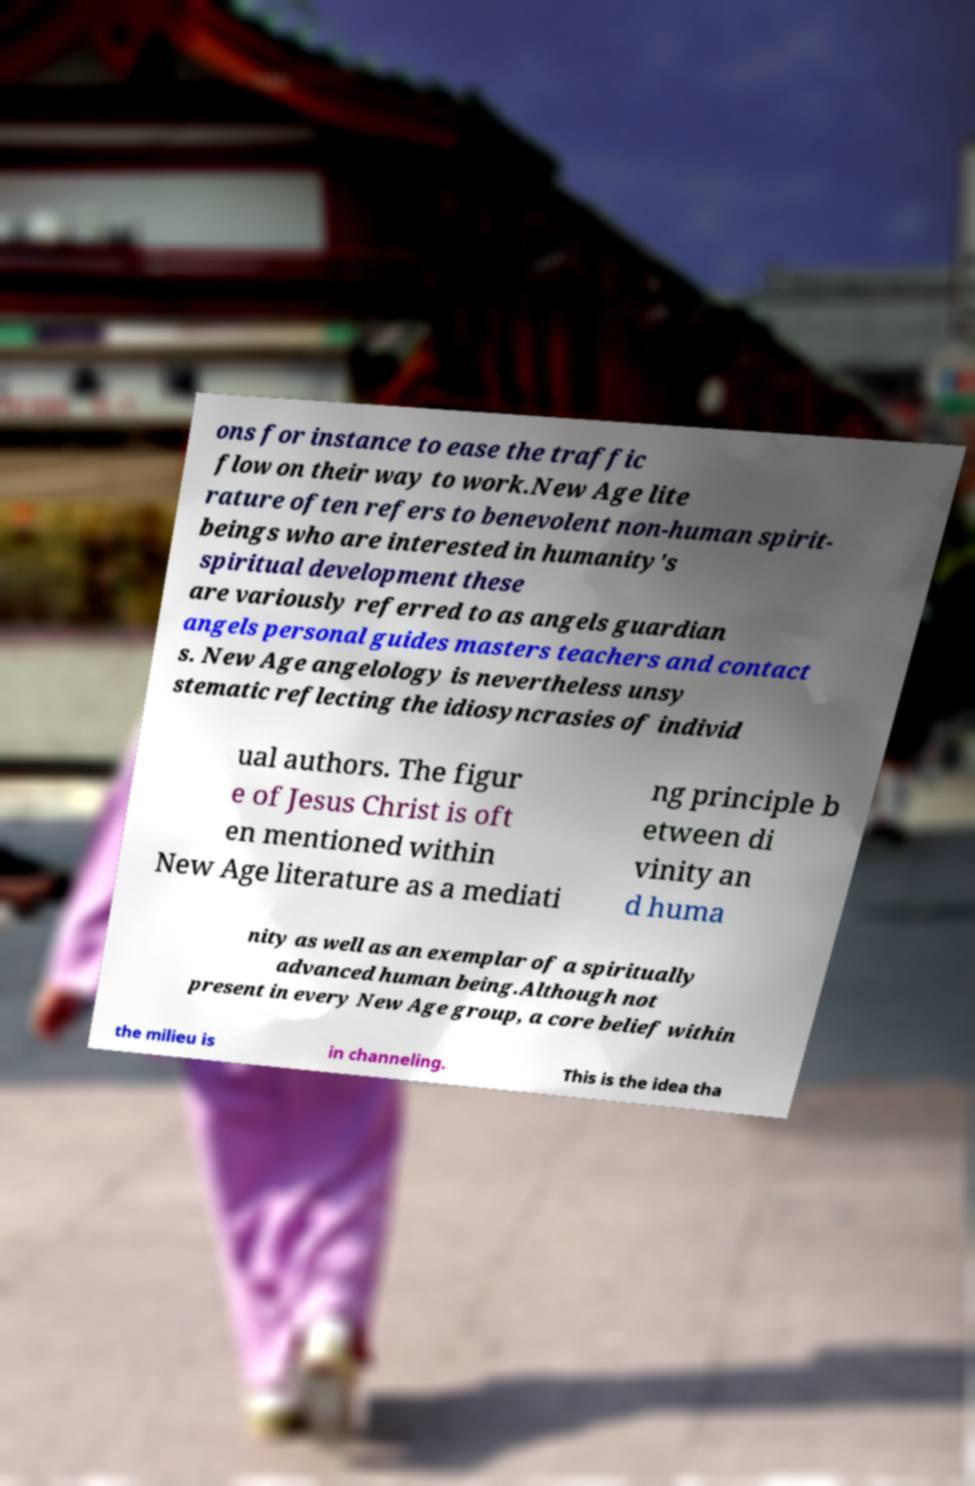Can you accurately transcribe the text from the provided image for me? ons for instance to ease the traffic flow on their way to work.New Age lite rature often refers to benevolent non-human spirit- beings who are interested in humanity's spiritual development these are variously referred to as angels guardian angels personal guides masters teachers and contact s. New Age angelology is nevertheless unsy stematic reflecting the idiosyncrasies of individ ual authors. The figur e of Jesus Christ is oft en mentioned within New Age literature as a mediati ng principle b etween di vinity an d huma nity as well as an exemplar of a spiritually advanced human being.Although not present in every New Age group, a core belief within the milieu is in channeling. This is the idea tha 